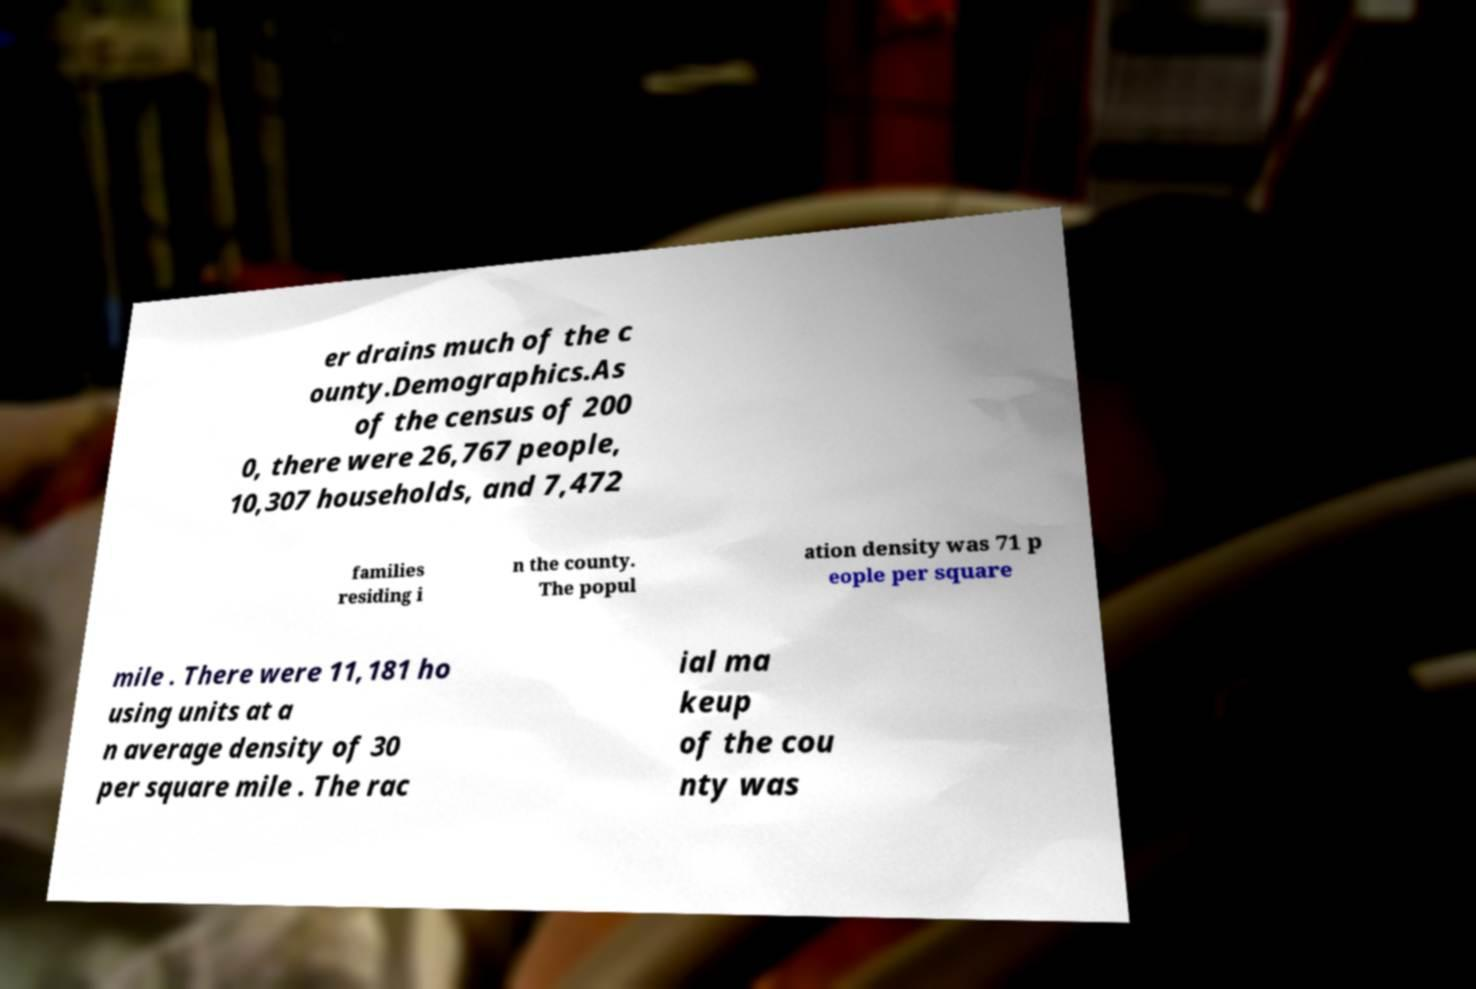I need the written content from this picture converted into text. Can you do that? er drains much of the c ounty.Demographics.As of the census of 200 0, there were 26,767 people, 10,307 households, and 7,472 families residing i n the county. The popul ation density was 71 p eople per square mile . There were 11,181 ho using units at a n average density of 30 per square mile . The rac ial ma keup of the cou nty was 